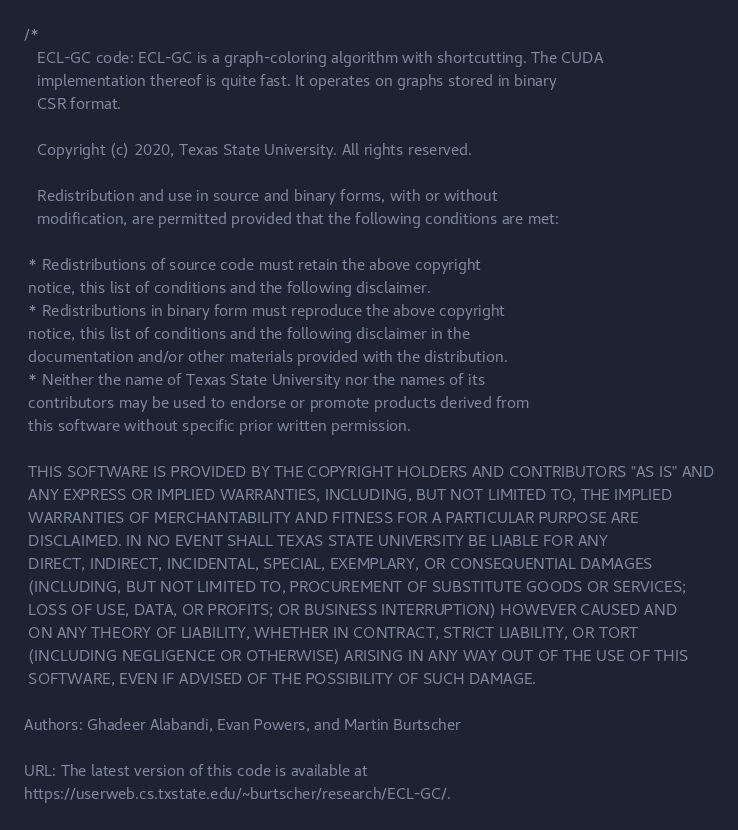Convert code to text. <code><loc_0><loc_0><loc_500><loc_500><_Cuda_>/*
   ECL-GC code: ECL-GC is a graph-coloring algorithm with shortcutting. The CUDA
   implementation thereof is quite fast. It operates on graphs stored in binary
   CSR format.

   Copyright (c) 2020, Texas State University. All rights reserved.

   Redistribution and use in source and binary forms, with or without
   modification, are permitted provided that the following conditions are met:

 * Redistributions of source code must retain the above copyright
 notice, this list of conditions and the following disclaimer.
 * Redistributions in binary form must reproduce the above copyright
 notice, this list of conditions and the following disclaimer in the
 documentation and/or other materials provided with the distribution.
 * Neither the name of Texas State University nor the names of its
 contributors may be used to endorse or promote products derived from
 this software without specific prior written permission.

 THIS SOFTWARE IS PROVIDED BY THE COPYRIGHT HOLDERS AND CONTRIBUTORS "AS IS" AND
 ANY EXPRESS OR IMPLIED WARRANTIES, INCLUDING, BUT NOT LIMITED TO, THE IMPLIED
 WARRANTIES OF MERCHANTABILITY AND FITNESS FOR A PARTICULAR PURPOSE ARE
 DISCLAIMED. IN NO EVENT SHALL TEXAS STATE UNIVERSITY BE LIABLE FOR ANY
 DIRECT, INDIRECT, INCIDENTAL, SPECIAL, EXEMPLARY, OR CONSEQUENTIAL DAMAGES
 (INCLUDING, BUT NOT LIMITED TO, PROCUREMENT OF SUBSTITUTE GOODS OR SERVICES;
 LOSS OF USE, DATA, OR PROFITS; OR BUSINESS INTERRUPTION) HOWEVER CAUSED AND
 ON ANY THEORY OF LIABILITY, WHETHER IN CONTRACT, STRICT LIABILITY, OR TORT
 (INCLUDING NEGLIGENCE OR OTHERWISE) ARISING IN ANY WAY OUT OF THE USE OF THIS
 SOFTWARE, EVEN IF ADVISED OF THE POSSIBILITY OF SUCH DAMAGE.

Authors: Ghadeer Alabandi, Evan Powers, and Martin Burtscher

URL: The latest version of this code is available at
https://userweb.cs.txstate.edu/~burtscher/research/ECL-GC/.
</code> 